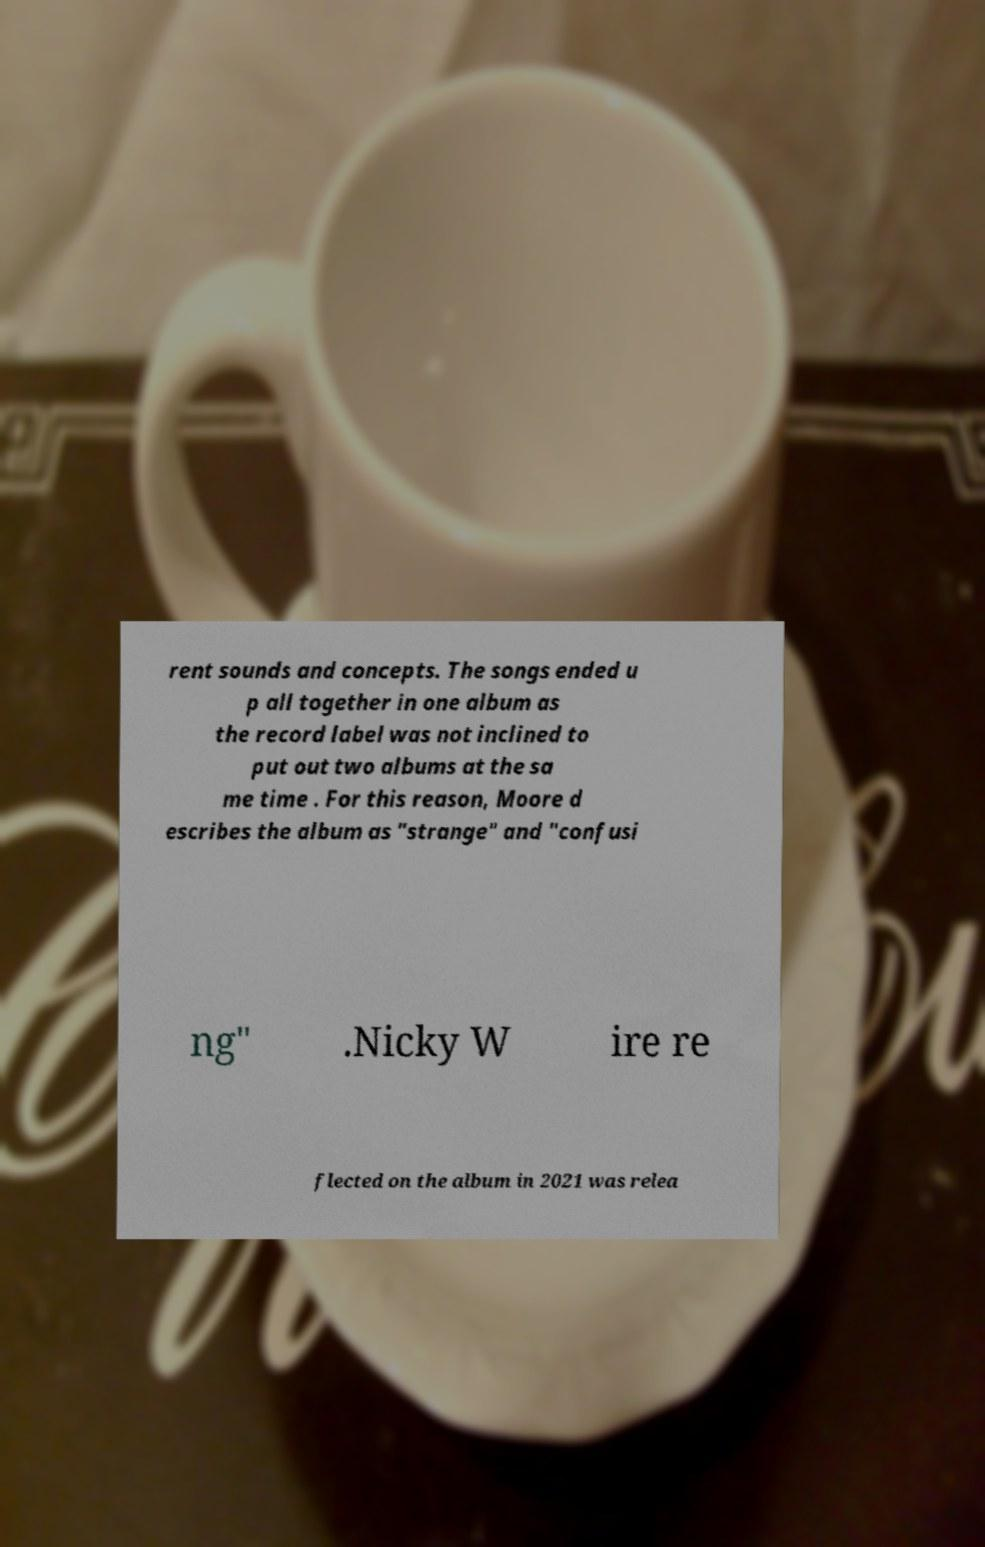Could you extract and type out the text from this image? rent sounds and concepts. The songs ended u p all together in one album as the record label was not inclined to put out two albums at the sa me time . For this reason, Moore d escribes the album as "strange" and "confusi ng" .Nicky W ire re flected on the album in 2021 was relea 